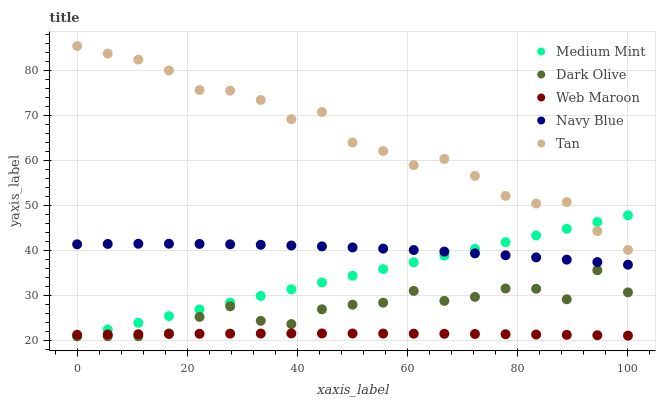Does Web Maroon have the minimum area under the curve?
Answer yes or no. Yes. Does Tan have the maximum area under the curve?
Answer yes or no. Yes. Does Navy Blue have the minimum area under the curve?
Answer yes or no. No. Does Navy Blue have the maximum area under the curve?
Answer yes or no. No. Is Medium Mint the smoothest?
Answer yes or no. Yes. Is Tan the roughest?
Answer yes or no. Yes. Is Navy Blue the smoothest?
Answer yes or no. No. Is Navy Blue the roughest?
Answer yes or no. No. Does Medium Mint have the lowest value?
Answer yes or no. Yes. Does Navy Blue have the lowest value?
Answer yes or no. No. Does Tan have the highest value?
Answer yes or no. Yes. Does Navy Blue have the highest value?
Answer yes or no. No. Is Dark Olive less than Navy Blue?
Answer yes or no. Yes. Is Tan greater than Dark Olive?
Answer yes or no. Yes. Does Medium Mint intersect Web Maroon?
Answer yes or no. Yes. Is Medium Mint less than Web Maroon?
Answer yes or no. No. Is Medium Mint greater than Web Maroon?
Answer yes or no. No. Does Dark Olive intersect Navy Blue?
Answer yes or no. No. 